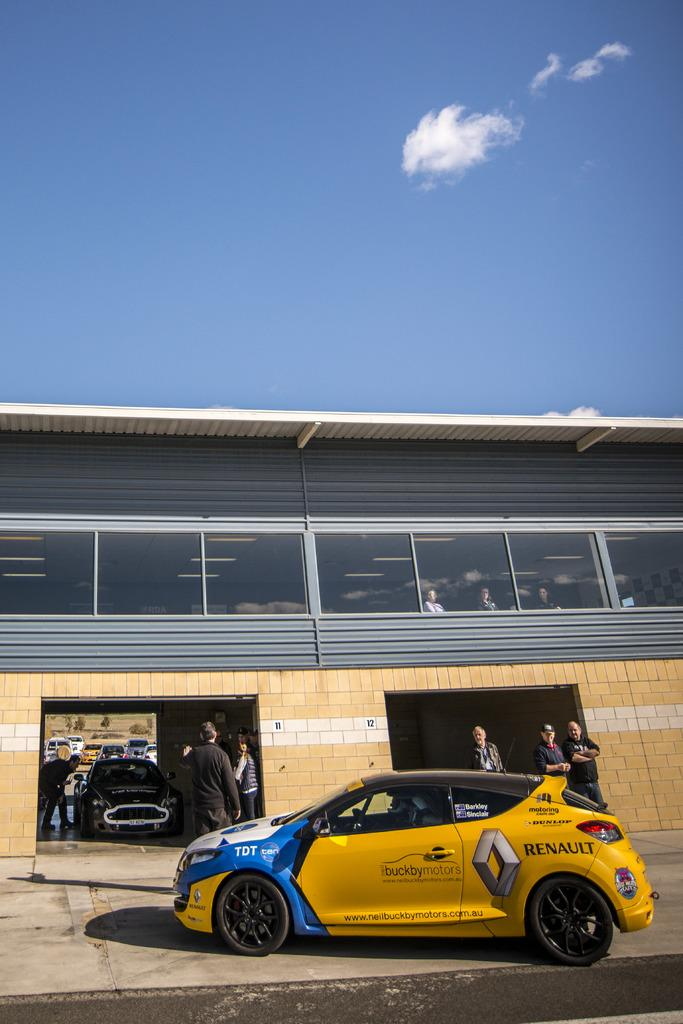Where is the setting of the image? The image is set outside of a city. What can be seen in the image? There is a group of persons in the image, and they are standing. What is the main object in the center of the image? There is a vesicle in the center of the image. What can be seen in the background of the image? There is sky visible in the background of the image, with clouds and at least one building. What type of behavior is exhibited by the spoon in the image? There is no spoon present in the image, so it is not possible to determine any behavior. 